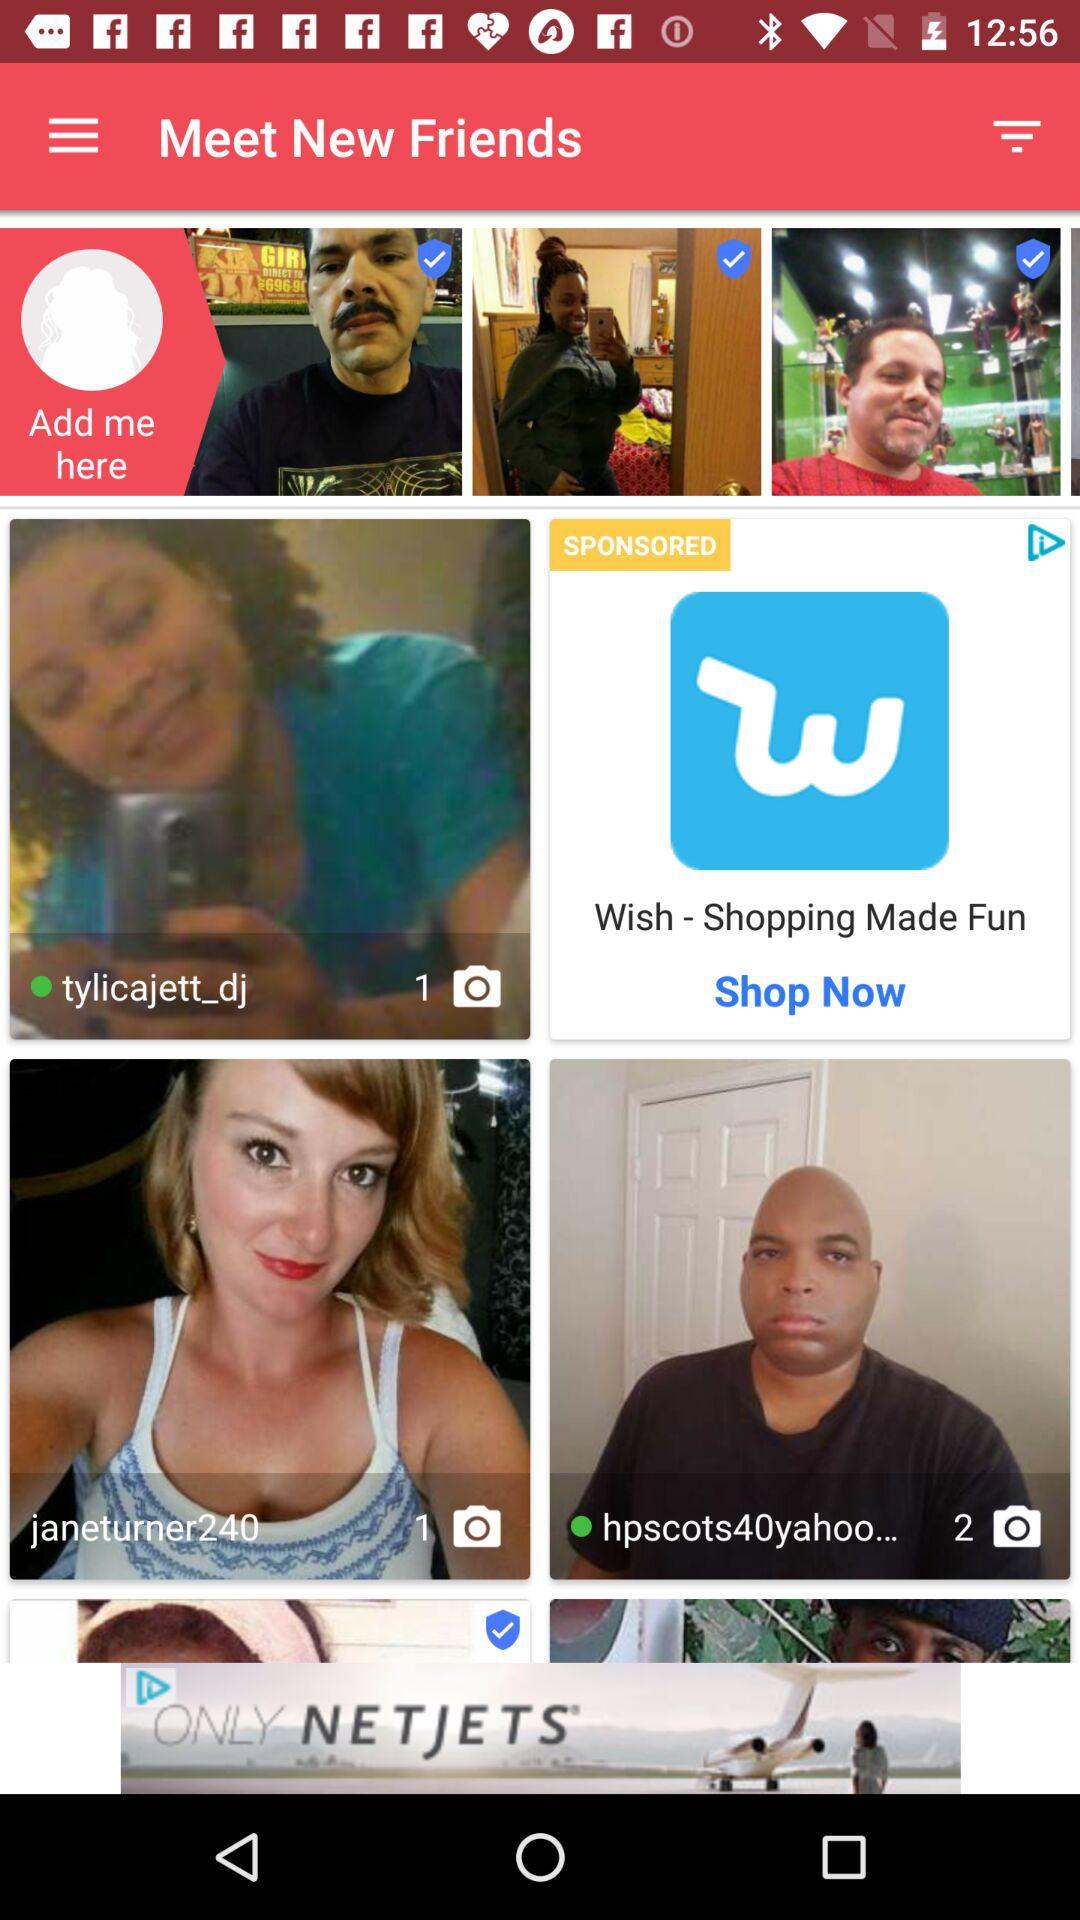How many photos does "hpscots40yahoo..." have? "hpscots40yahoo..." has 2 photos. 